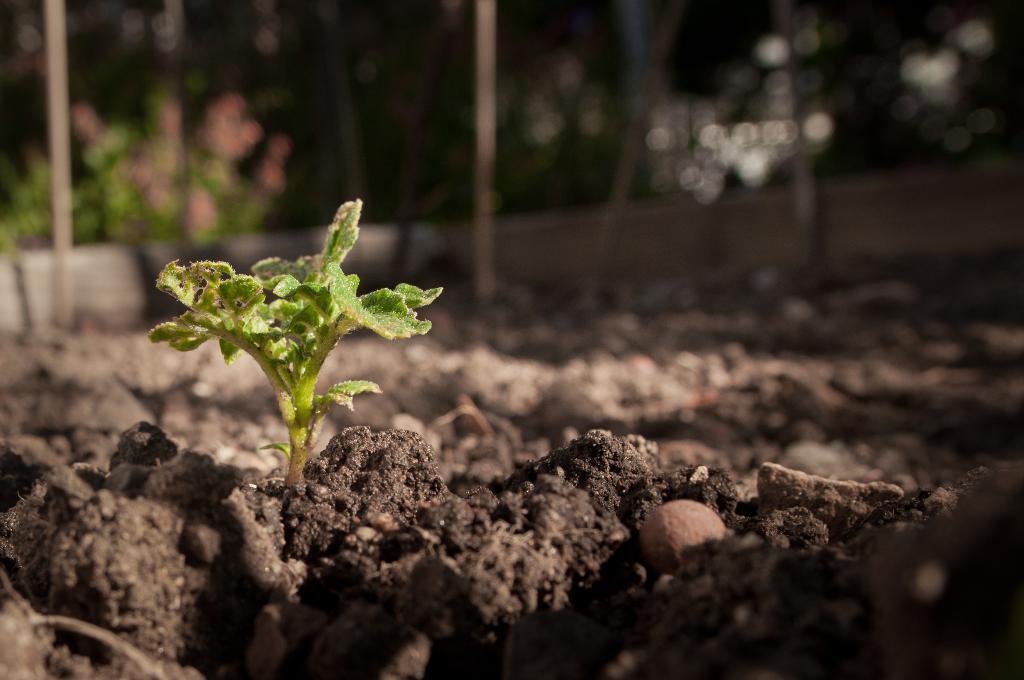Could you give a brief overview of what you see in this image? In this picture we can see a plant, soil and in the background we can see trees, poles and it is blurry. 